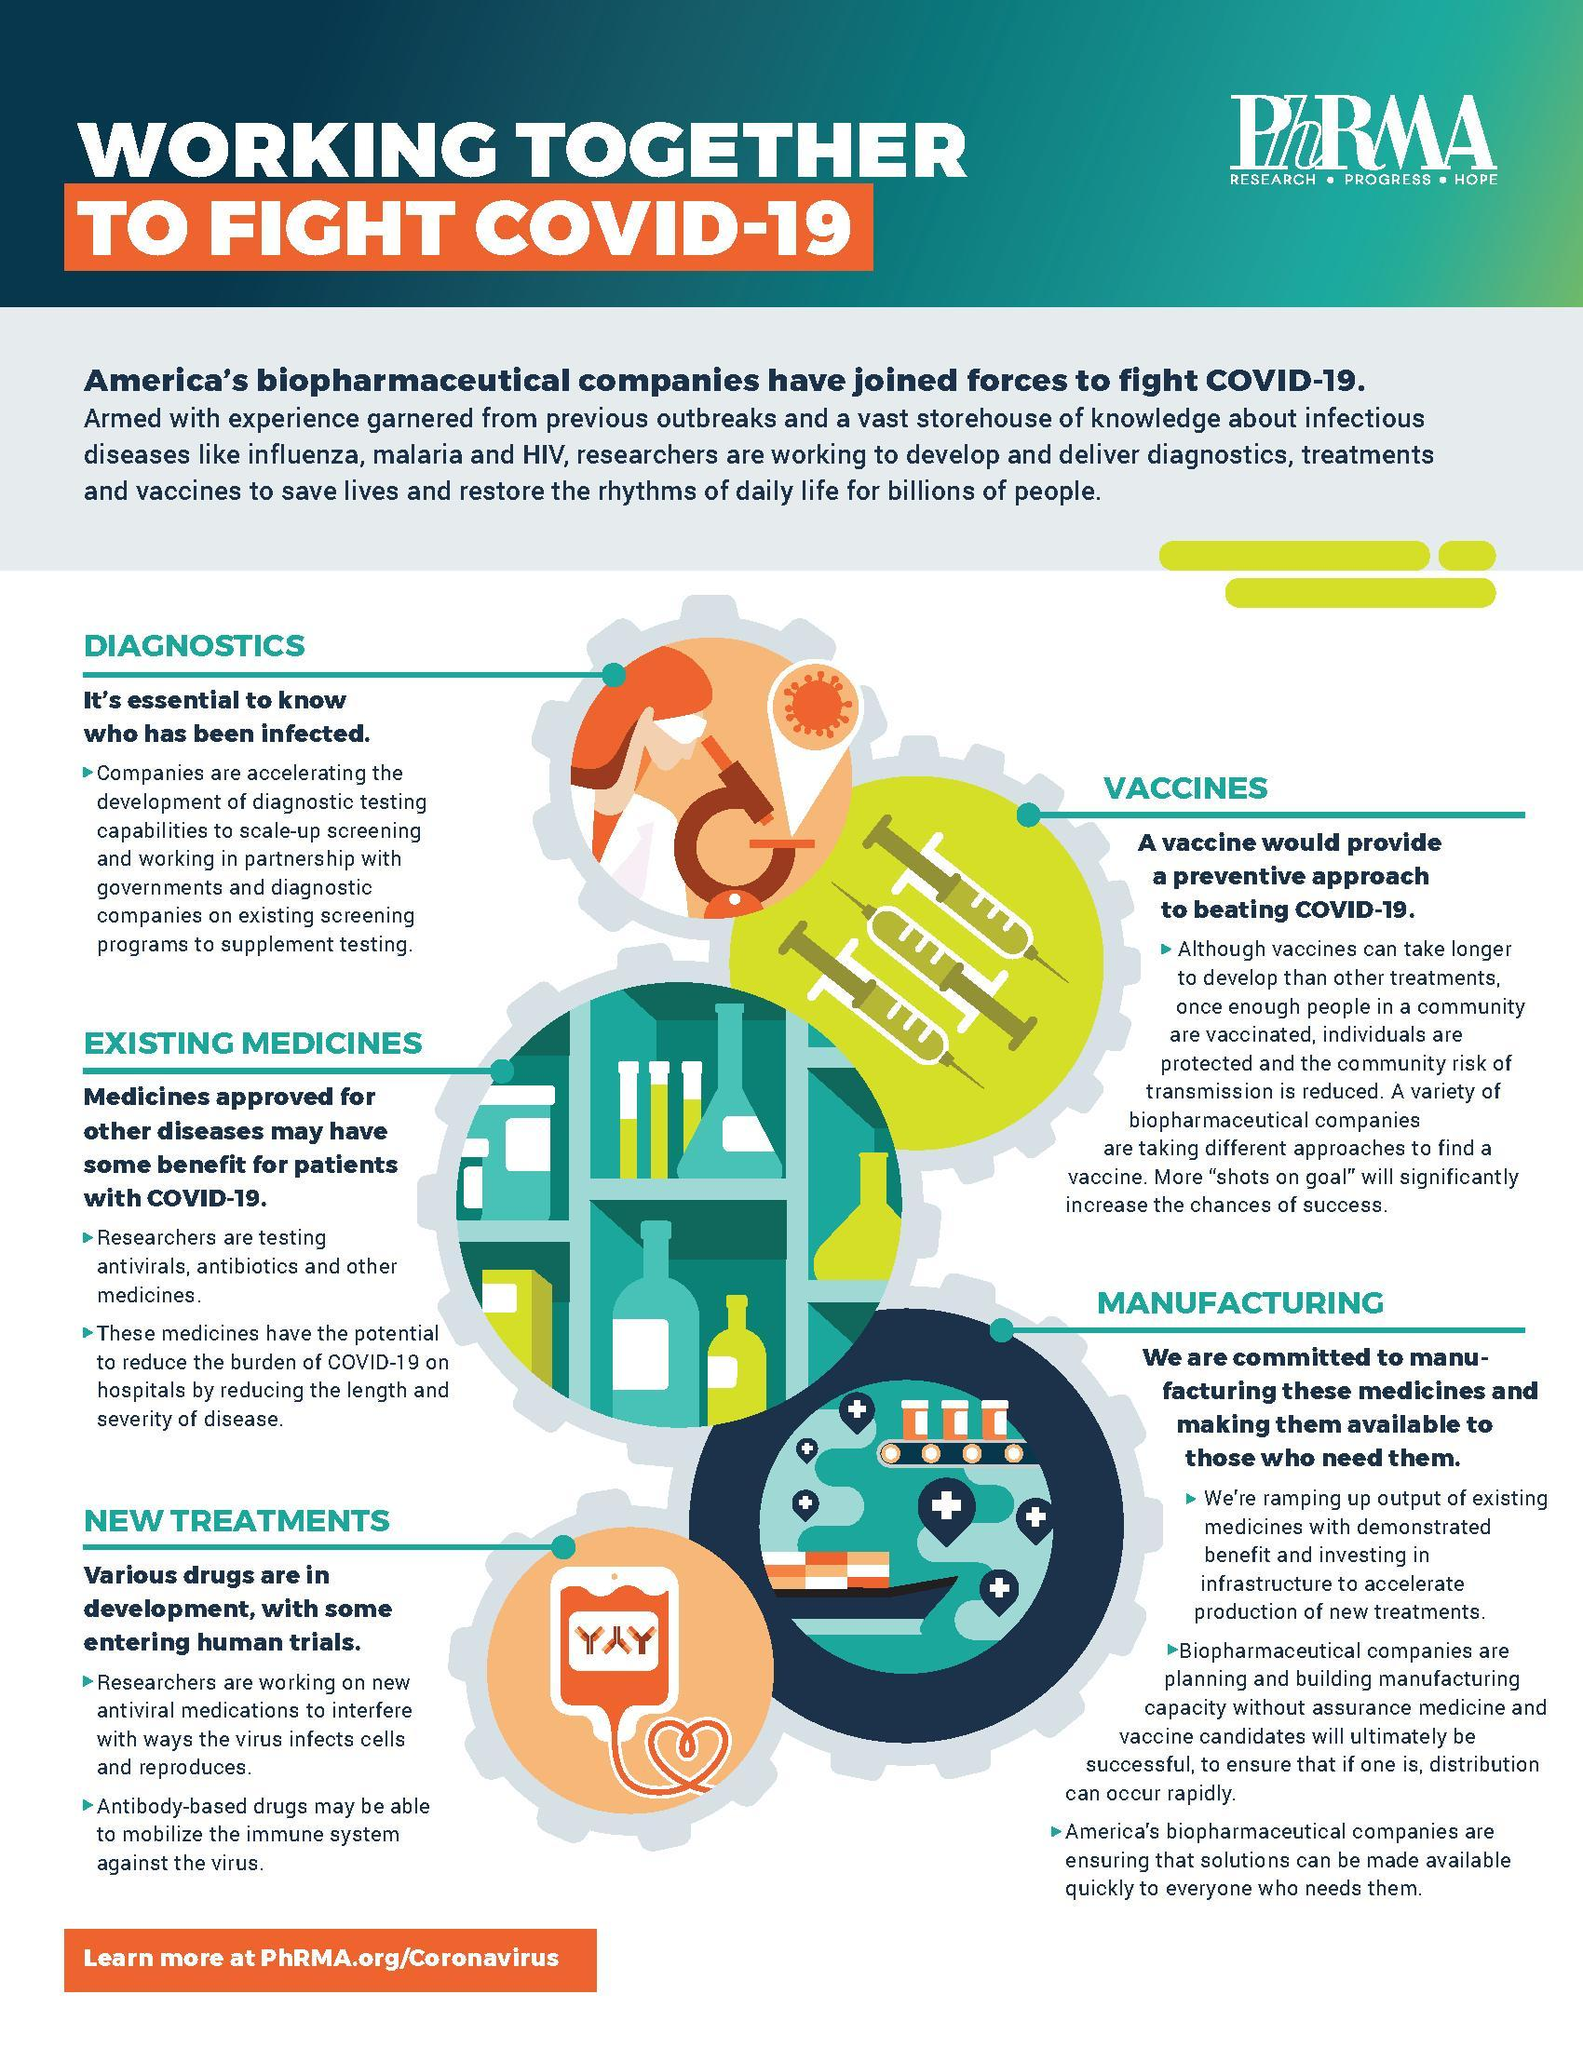How many points are under the heading "Manufacturing"?
Answer the question with a short phrase. 3 How many points are under the heading "Diagnostics"? 1 How many points are under the heading "Vaccines"? 1 How many points are under the heading "New Treatments"? 2 How many points are under the heading "Existing Medicines"? 2 